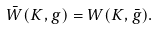Convert formula to latex. <formula><loc_0><loc_0><loc_500><loc_500>\bar { W } ( K , g ) = W ( K , \bar { g } ) .</formula> 